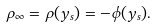Convert formula to latex. <formula><loc_0><loc_0><loc_500><loc_500>\rho _ { \infty } = \rho ( y _ { s } ) = - \phi ( y _ { s } ) .</formula> 